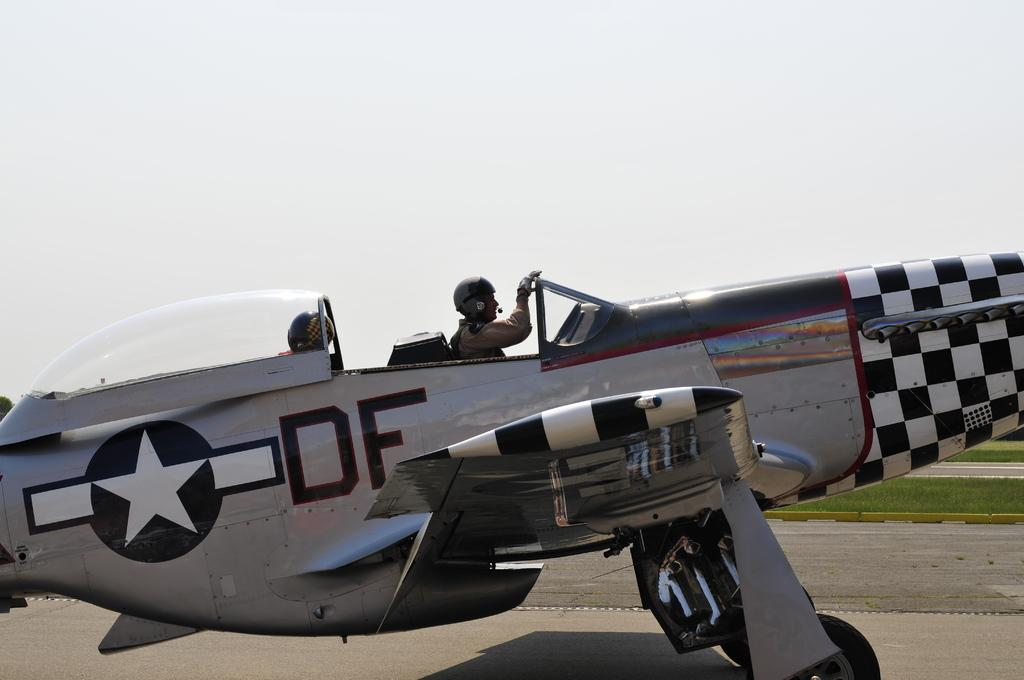<image>
Create a compact narrative representing the image presented. A silver World War II era fighter that says DF on the side is being taxied on a runway. 